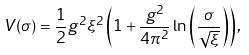<formula> <loc_0><loc_0><loc_500><loc_500>V ( \sigma ) = \frac { 1 } { 2 } g ^ { 2 } \xi ^ { 2 } \left ( 1 + \frac { g ^ { 2 } } { 4 \pi ^ { 2 } } \ln \left ( \frac { \sigma } { \sqrt { \xi } } \right ) \right ) ,</formula> 